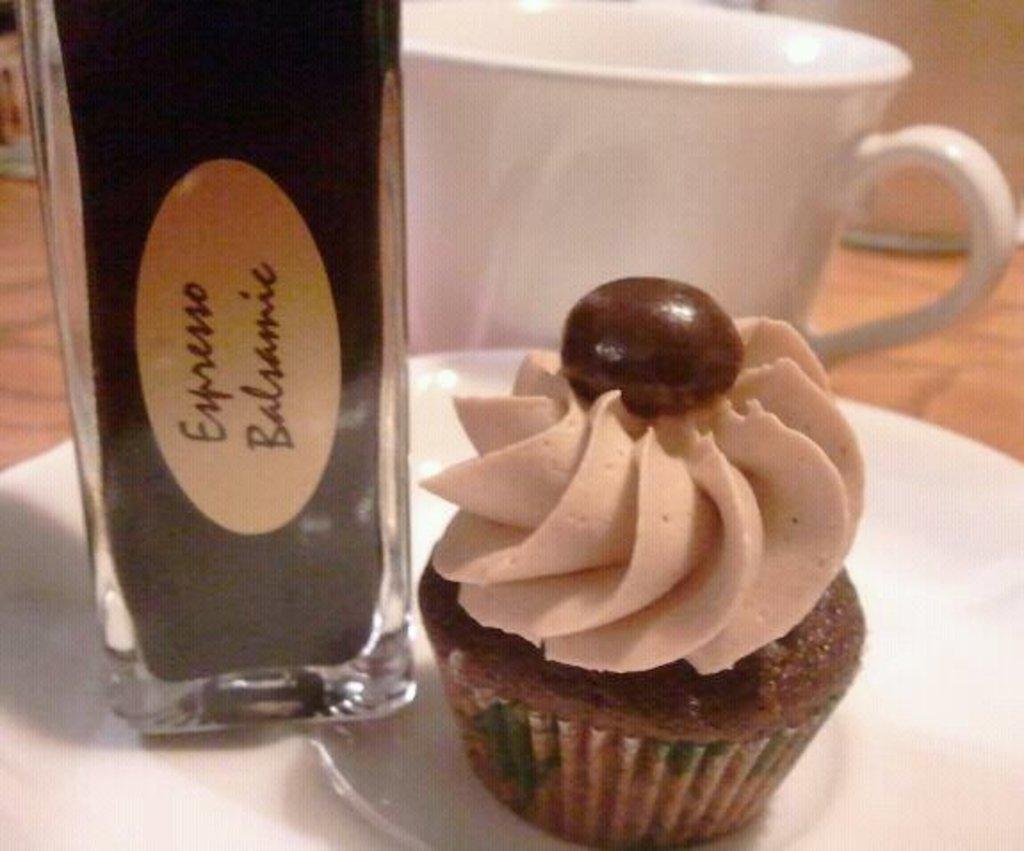What kind of drink is in the glass bottle?
Offer a very short reply. Expresso balsamic. 